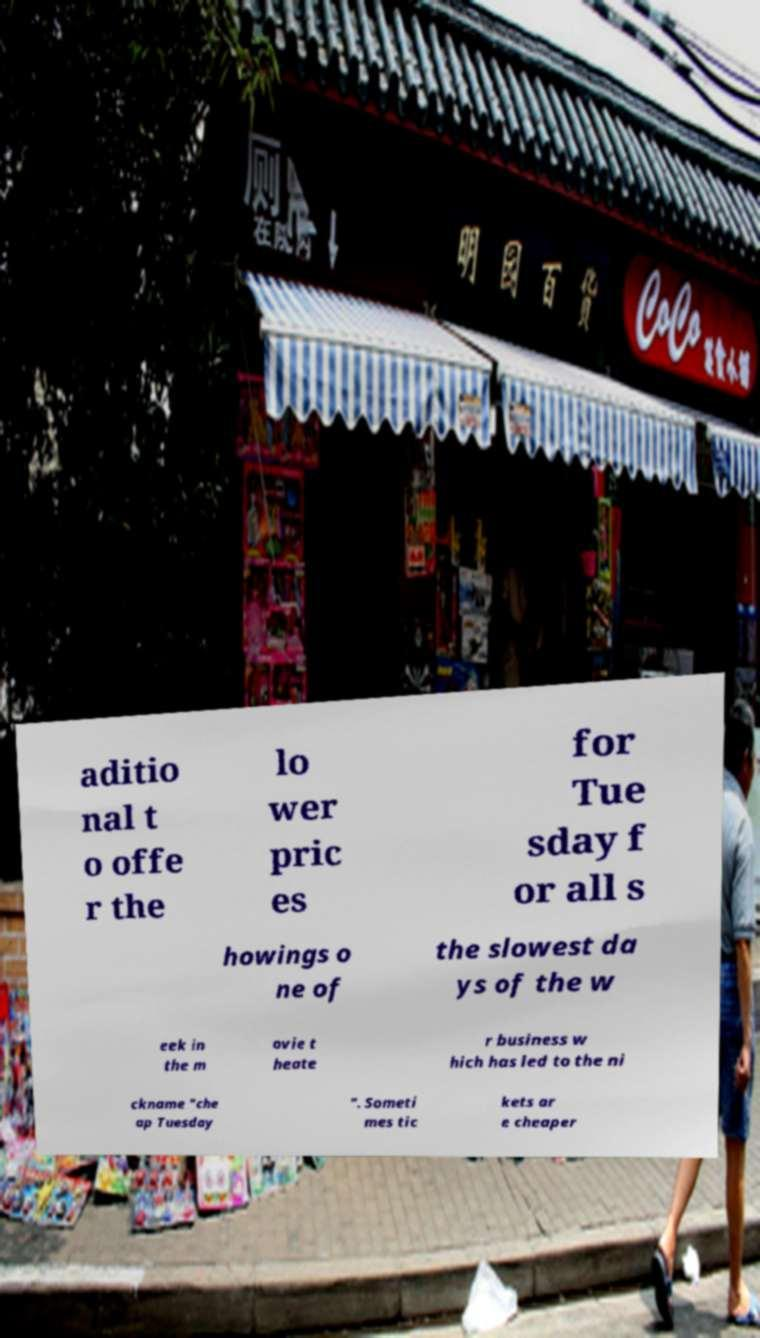Could you extract and type out the text from this image? aditio nal t o offe r the lo wer pric es for Tue sday f or all s howings o ne of the slowest da ys of the w eek in the m ovie t heate r business w hich has led to the ni ckname "che ap Tuesday ". Someti mes tic kets ar e cheaper 